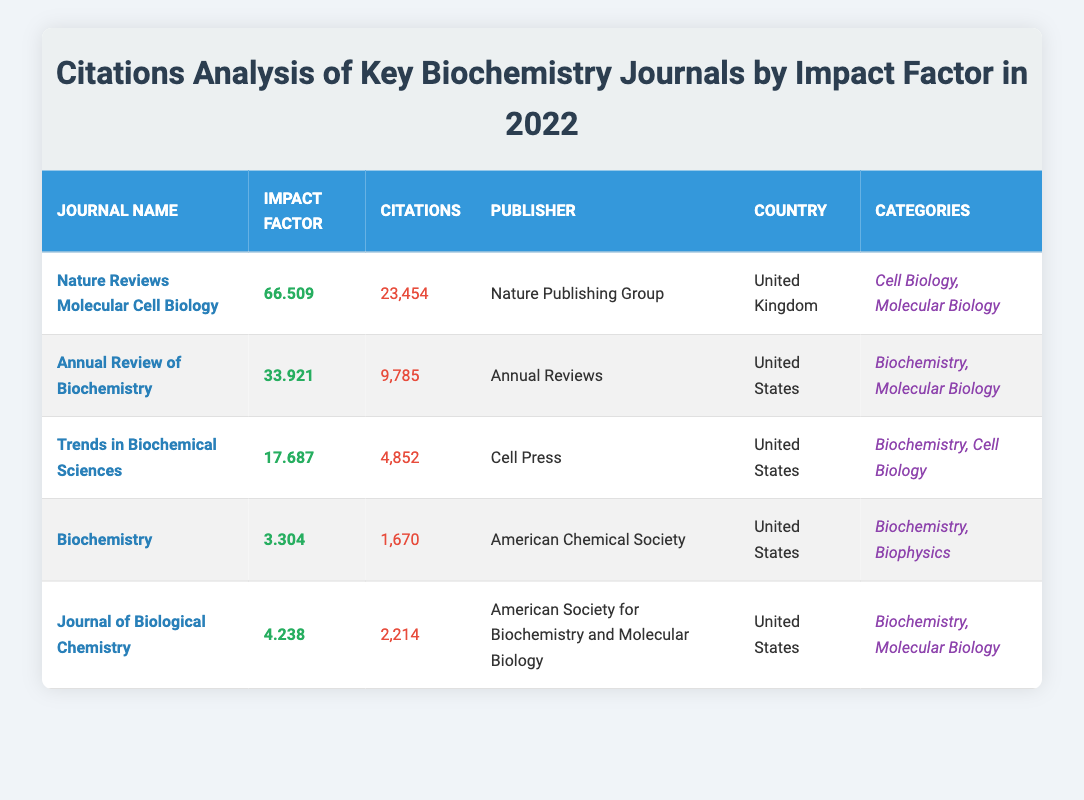What is the highest impact factor among the journals listed? By looking at the "Impact Factor" column, the highest value is 66.509 which corresponds to the journal "Nature Reviews Molecular Cell Biology".
Answer: 66.509 How many citations did the "Annual Review of Biochemistry" receive? Referring to the "Citations" column for the "Annual Review of Biochemistry", it shows a count of 9785 citations.
Answer: 9785 Which journal published in the United Kingdom has the most citations? From the table, "Nature Reviews Molecular Cell Biology" is the only journal published in the United Kingdom, and it has 23454 citations, which is also the highest among all journals listed.
Answer: Nature Reviews Molecular Cell Biology Is the "Journal of Biological Chemistry" considered to fall under the category of Biophysics? Checking the "Categories" column for the "Journal of Biological Chemistry", it lists "Biochemistry" and "Molecular Biology," but does not include "Biophysics." Therefore, the statement is false.
Answer: No What is the difference in citations between "Trends in Biochemical Sciences" and "Biochemistry"? The citation for "Trends in Biochemical Sciences" is 4852, while for "Biochemistry" it is 1670. The difference is 4852 - 1670 = 3182.
Answer: 3182 If we combine the citations from all journals listed, what is the total number of citations? Adding the citations from all journals: 23454 + 9785 + 4852 + 1670 + 2214 = 38775. Thus, the total number of citations is 38775.
Answer: 38775 Which country has the most journals listed in this analysis? There are four journals from the United States and one from the United Kingdom. Since the United States has the highest number of entries, it has the most journals listed in this analysis.
Answer: United States What is the average impact factor of the "Biochemistry" journals listed? To find the average impact factor, first sum the impact factors: 66.509 + 33.921 + 17.687 + 3.304 + 4.238 = 125.659. There are 5 journals, so the average is calculated as 125.659 / 5 = 25.1318.
Answer: 25.1318 Does the "Nature Reviews Molecular Cell Biology" have more citations than the total citations of both "Biochemistry" and "Journal of Biological Chemistry" combined? The total citations for "Biochemistry" and "Journal of Biological Chemistry" are 1670 + 2214 = 3884. "Nature Reviews Molecular Cell Biology" has 23454 citations, which is indeed greater than 3884. Thus, the answer is yes.
Answer: Yes 